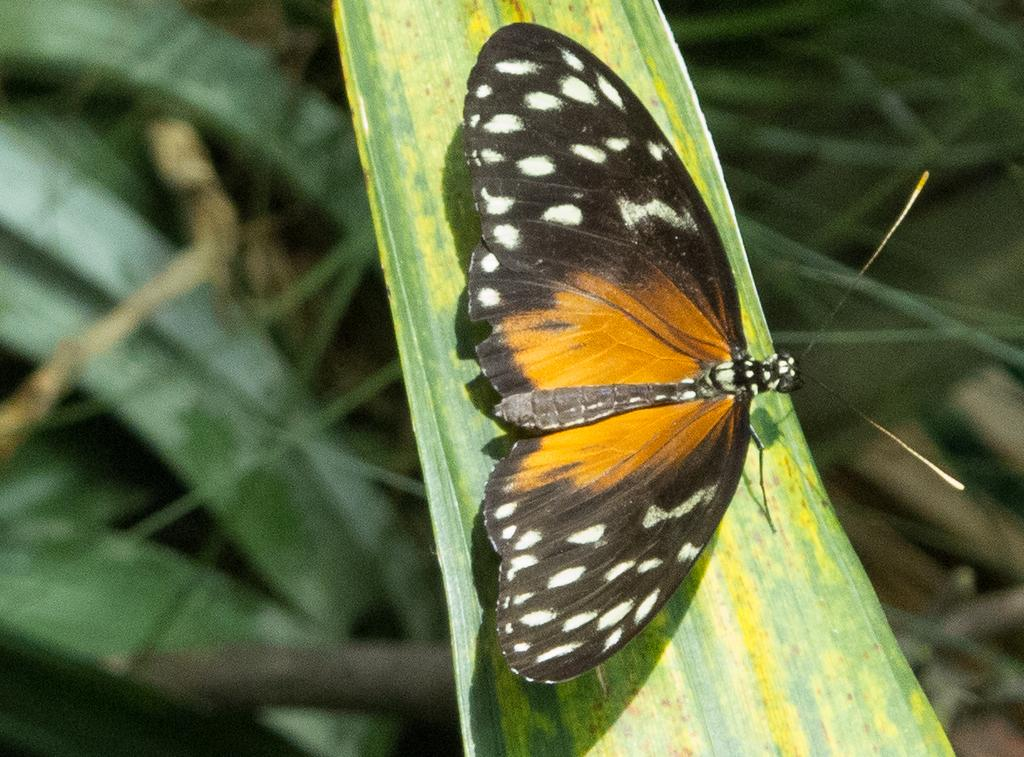What is the main subject of the image? There is a butterfly in the image. Where is the butterfly located? The butterfly is on the grass. What type of pain is the butterfly experiencing in the image? There is no indication in the image that the butterfly is experiencing any pain. What type of seat is the butterfly sitting on in the image? There is no seat present in the image, as the butterfly is on the grass. 